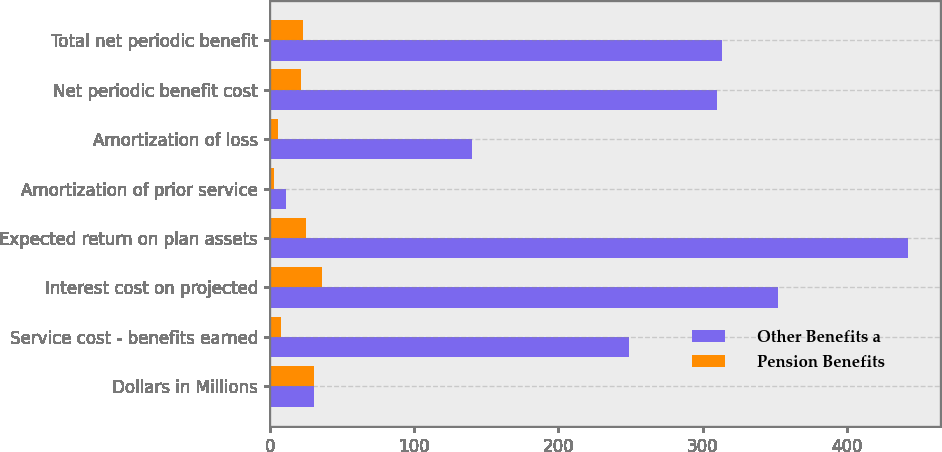Convert chart. <chart><loc_0><loc_0><loc_500><loc_500><stacked_bar_chart><ecel><fcel>Dollars in Millions<fcel>Service cost - benefits earned<fcel>Interest cost on projected<fcel>Expected return on plan assets<fcel>Amortization of prior service<fcel>Amortization of loss<fcel>Net periodic benefit cost<fcel>Total net periodic benefit<nl><fcel>Other Benefits a<fcel>30.5<fcel>249<fcel>352<fcel>442<fcel>11<fcel>140<fcel>310<fcel>313<nl><fcel>Pension Benefits<fcel>30.5<fcel>8<fcel>36<fcel>25<fcel>3<fcel>6<fcel>22<fcel>23<nl></chart> 